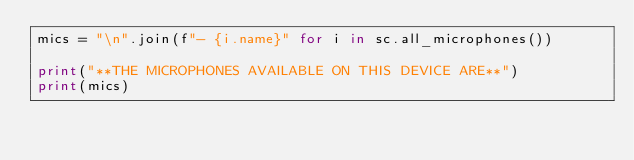<code> <loc_0><loc_0><loc_500><loc_500><_Python_>mics = "\n".join(f"- {i.name}" for i in sc.all_microphones())

print("**THE MICROPHONES AVAILABLE ON THIS DEVICE ARE**")
print(mics)</code> 